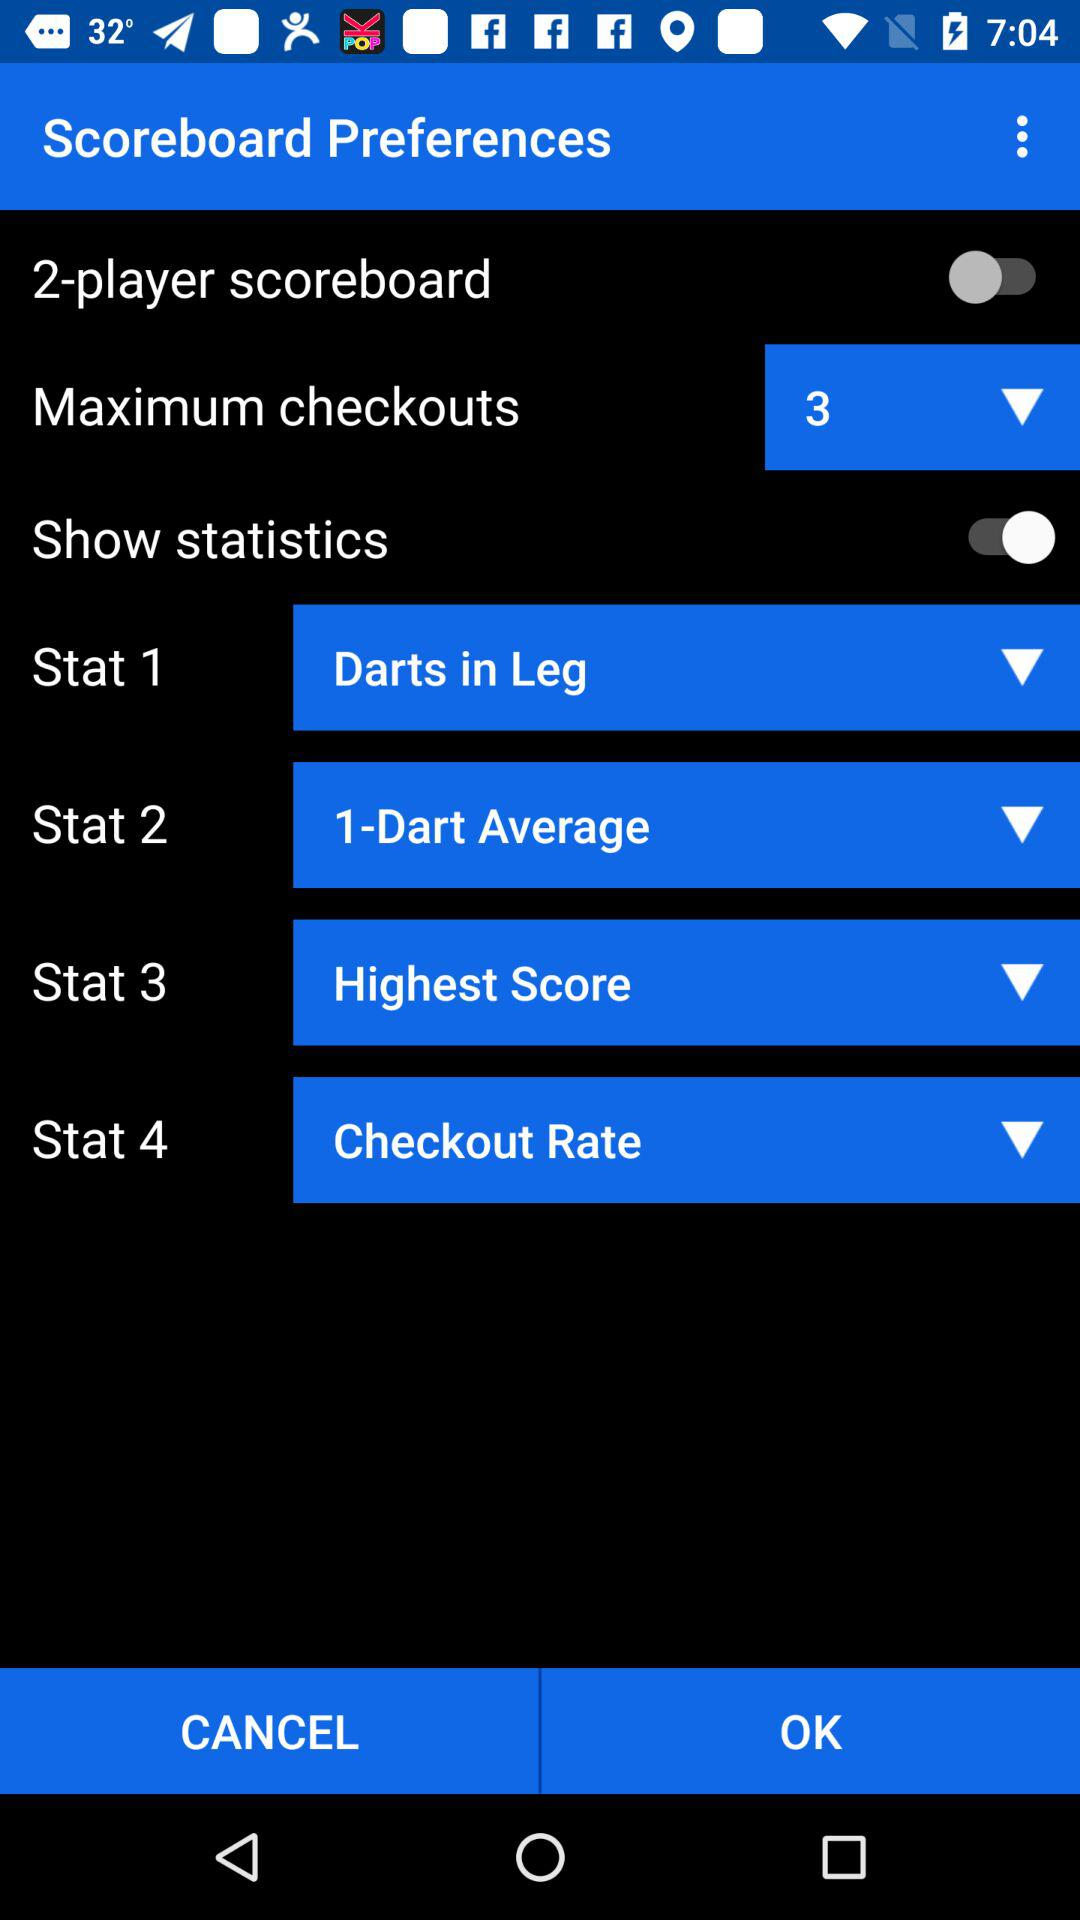Which option is selected in "Stat 1"? The selected option is "Darts in Leg". 